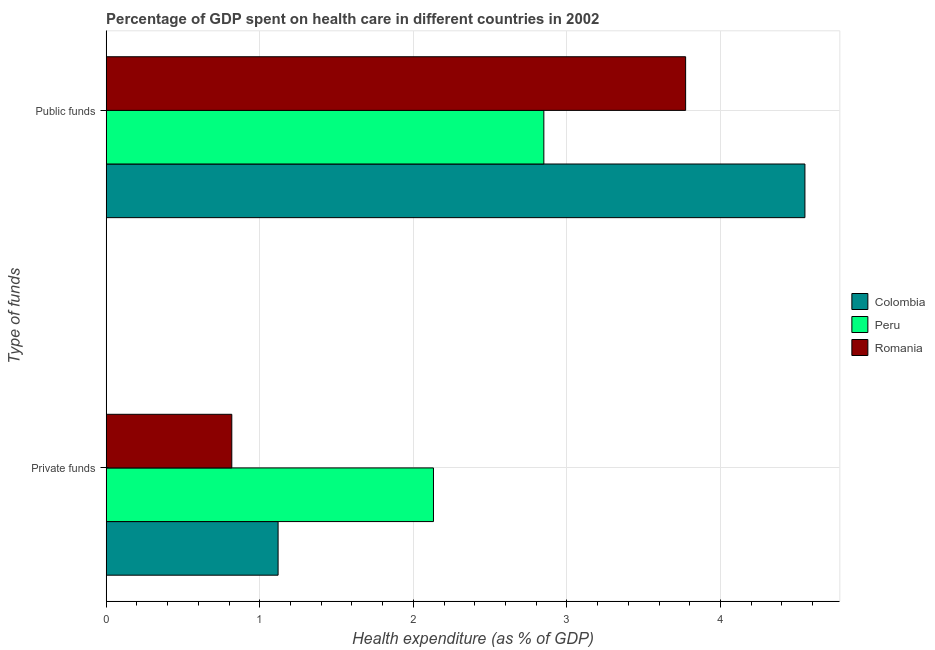What is the label of the 1st group of bars from the top?
Ensure brevity in your answer.  Public funds. What is the amount of private funds spent in healthcare in Colombia?
Make the answer very short. 1.12. Across all countries, what is the maximum amount of public funds spent in healthcare?
Provide a short and direct response. 4.55. Across all countries, what is the minimum amount of private funds spent in healthcare?
Give a very brief answer. 0.82. In which country was the amount of private funds spent in healthcare minimum?
Your response must be concise. Romania. What is the total amount of private funds spent in healthcare in the graph?
Provide a succinct answer. 4.07. What is the difference between the amount of private funds spent in healthcare in Romania and that in Colombia?
Your answer should be compact. -0.3. What is the difference between the amount of private funds spent in healthcare in Peru and the amount of public funds spent in healthcare in Colombia?
Ensure brevity in your answer.  -2.42. What is the average amount of private funds spent in healthcare per country?
Keep it short and to the point. 1.36. What is the difference between the amount of private funds spent in healthcare and amount of public funds spent in healthcare in Peru?
Offer a terse response. -0.72. In how many countries, is the amount of public funds spent in healthcare greater than 0.8 %?
Provide a succinct answer. 3. What is the ratio of the amount of public funds spent in healthcare in Peru to that in Colombia?
Give a very brief answer. 0.63. What does the 3rd bar from the top in Private funds represents?
Provide a short and direct response. Colombia. How many bars are there?
Keep it short and to the point. 6. What is the difference between two consecutive major ticks on the X-axis?
Keep it short and to the point. 1. Does the graph contain grids?
Keep it short and to the point. Yes. Where does the legend appear in the graph?
Provide a succinct answer. Center right. How many legend labels are there?
Provide a succinct answer. 3. What is the title of the graph?
Your answer should be compact. Percentage of GDP spent on health care in different countries in 2002. What is the label or title of the X-axis?
Offer a terse response. Health expenditure (as % of GDP). What is the label or title of the Y-axis?
Your response must be concise. Type of funds. What is the Health expenditure (as % of GDP) in Colombia in Private funds?
Make the answer very short. 1.12. What is the Health expenditure (as % of GDP) in Peru in Private funds?
Make the answer very short. 2.13. What is the Health expenditure (as % of GDP) in Romania in Private funds?
Ensure brevity in your answer.  0.82. What is the Health expenditure (as % of GDP) in Colombia in Public funds?
Ensure brevity in your answer.  4.55. What is the Health expenditure (as % of GDP) of Peru in Public funds?
Provide a succinct answer. 2.85. What is the Health expenditure (as % of GDP) of Romania in Public funds?
Make the answer very short. 3.77. Across all Type of funds, what is the maximum Health expenditure (as % of GDP) in Colombia?
Offer a terse response. 4.55. Across all Type of funds, what is the maximum Health expenditure (as % of GDP) of Peru?
Provide a succinct answer. 2.85. Across all Type of funds, what is the maximum Health expenditure (as % of GDP) of Romania?
Your answer should be very brief. 3.77. Across all Type of funds, what is the minimum Health expenditure (as % of GDP) in Colombia?
Your response must be concise. 1.12. Across all Type of funds, what is the minimum Health expenditure (as % of GDP) of Peru?
Provide a succinct answer. 2.13. Across all Type of funds, what is the minimum Health expenditure (as % of GDP) of Romania?
Make the answer very short. 0.82. What is the total Health expenditure (as % of GDP) in Colombia in the graph?
Provide a succinct answer. 5.67. What is the total Health expenditure (as % of GDP) of Peru in the graph?
Give a very brief answer. 4.98. What is the total Health expenditure (as % of GDP) of Romania in the graph?
Give a very brief answer. 4.59. What is the difference between the Health expenditure (as % of GDP) of Colombia in Private funds and that in Public funds?
Make the answer very short. -3.43. What is the difference between the Health expenditure (as % of GDP) in Peru in Private funds and that in Public funds?
Offer a terse response. -0.72. What is the difference between the Health expenditure (as % of GDP) in Romania in Private funds and that in Public funds?
Your answer should be compact. -2.96. What is the difference between the Health expenditure (as % of GDP) of Colombia in Private funds and the Health expenditure (as % of GDP) of Peru in Public funds?
Offer a very short reply. -1.73. What is the difference between the Health expenditure (as % of GDP) in Colombia in Private funds and the Health expenditure (as % of GDP) in Romania in Public funds?
Ensure brevity in your answer.  -2.65. What is the difference between the Health expenditure (as % of GDP) in Peru in Private funds and the Health expenditure (as % of GDP) in Romania in Public funds?
Provide a succinct answer. -1.64. What is the average Health expenditure (as % of GDP) in Colombia per Type of funds?
Offer a terse response. 2.83. What is the average Health expenditure (as % of GDP) of Peru per Type of funds?
Offer a terse response. 2.49. What is the average Health expenditure (as % of GDP) of Romania per Type of funds?
Provide a succinct answer. 2.3. What is the difference between the Health expenditure (as % of GDP) of Colombia and Health expenditure (as % of GDP) of Peru in Private funds?
Your response must be concise. -1.01. What is the difference between the Health expenditure (as % of GDP) of Colombia and Health expenditure (as % of GDP) of Romania in Private funds?
Offer a very short reply. 0.3. What is the difference between the Health expenditure (as % of GDP) of Peru and Health expenditure (as % of GDP) of Romania in Private funds?
Your answer should be very brief. 1.31. What is the difference between the Health expenditure (as % of GDP) in Colombia and Health expenditure (as % of GDP) in Romania in Public funds?
Ensure brevity in your answer.  0.78. What is the difference between the Health expenditure (as % of GDP) in Peru and Health expenditure (as % of GDP) in Romania in Public funds?
Your answer should be compact. -0.92. What is the ratio of the Health expenditure (as % of GDP) of Colombia in Private funds to that in Public funds?
Make the answer very short. 0.25. What is the ratio of the Health expenditure (as % of GDP) of Peru in Private funds to that in Public funds?
Provide a short and direct response. 0.75. What is the ratio of the Health expenditure (as % of GDP) in Romania in Private funds to that in Public funds?
Keep it short and to the point. 0.22. What is the difference between the highest and the second highest Health expenditure (as % of GDP) in Colombia?
Provide a short and direct response. 3.43. What is the difference between the highest and the second highest Health expenditure (as % of GDP) in Peru?
Your response must be concise. 0.72. What is the difference between the highest and the second highest Health expenditure (as % of GDP) of Romania?
Your response must be concise. 2.96. What is the difference between the highest and the lowest Health expenditure (as % of GDP) of Colombia?
Provide a succinct answer. 3.43. What is the difference between the highest and the lowest Health expenditure (as % of GDP) of Peru?
Your response must be concise. 0.72. What is the difference between the highest and the lowest Health expenditure (as % of GDP) of Romania?
Keep it short and to the point. 2.96. 